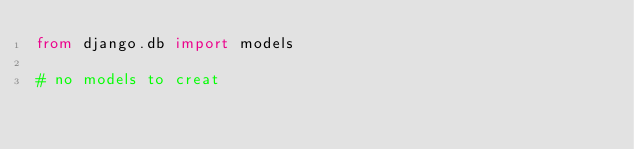<code> <loc_0><loc_0><loc_500><loc_500><_Python_>from django.db import models

# no models to creat
</code> 